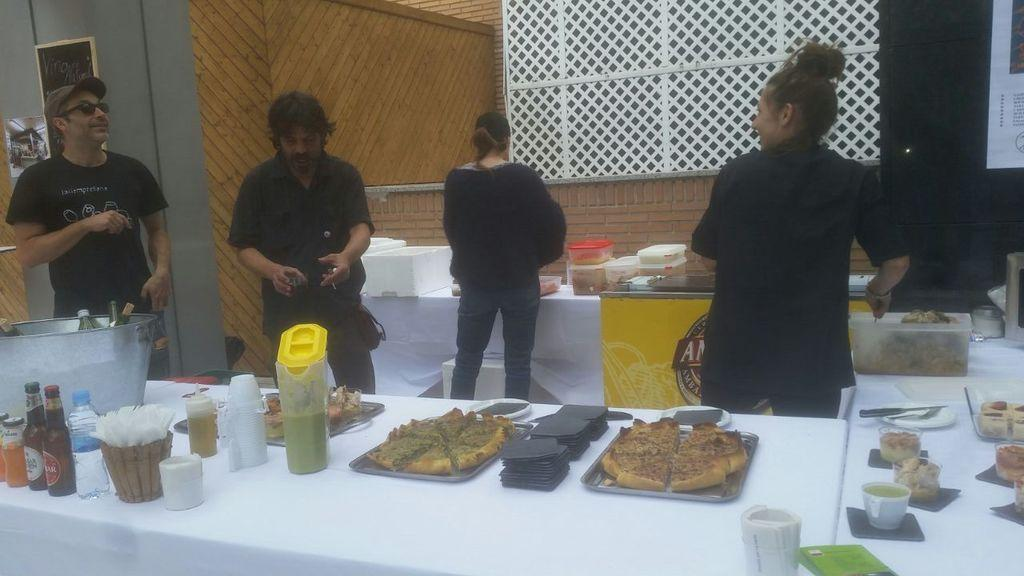How many people are present in the image? There are 2 men and 2 women in the image, making a total of 4 people. What is the primary object in the image? There is a table in the image. What items can be found on the table? Food material, a plate, a jar, a cup, a tissue box, a water bottle, a wine bottle, a bucket, boxes, and a food container are present on the table. Where is the mom sitting in the image? There is no mention of a mom in the image, so we cannot determine her location. What type of desk is visible in the image? There is no desk present in the image. Is there a doll sitting on the table in the image? There is no doll present in the image. 